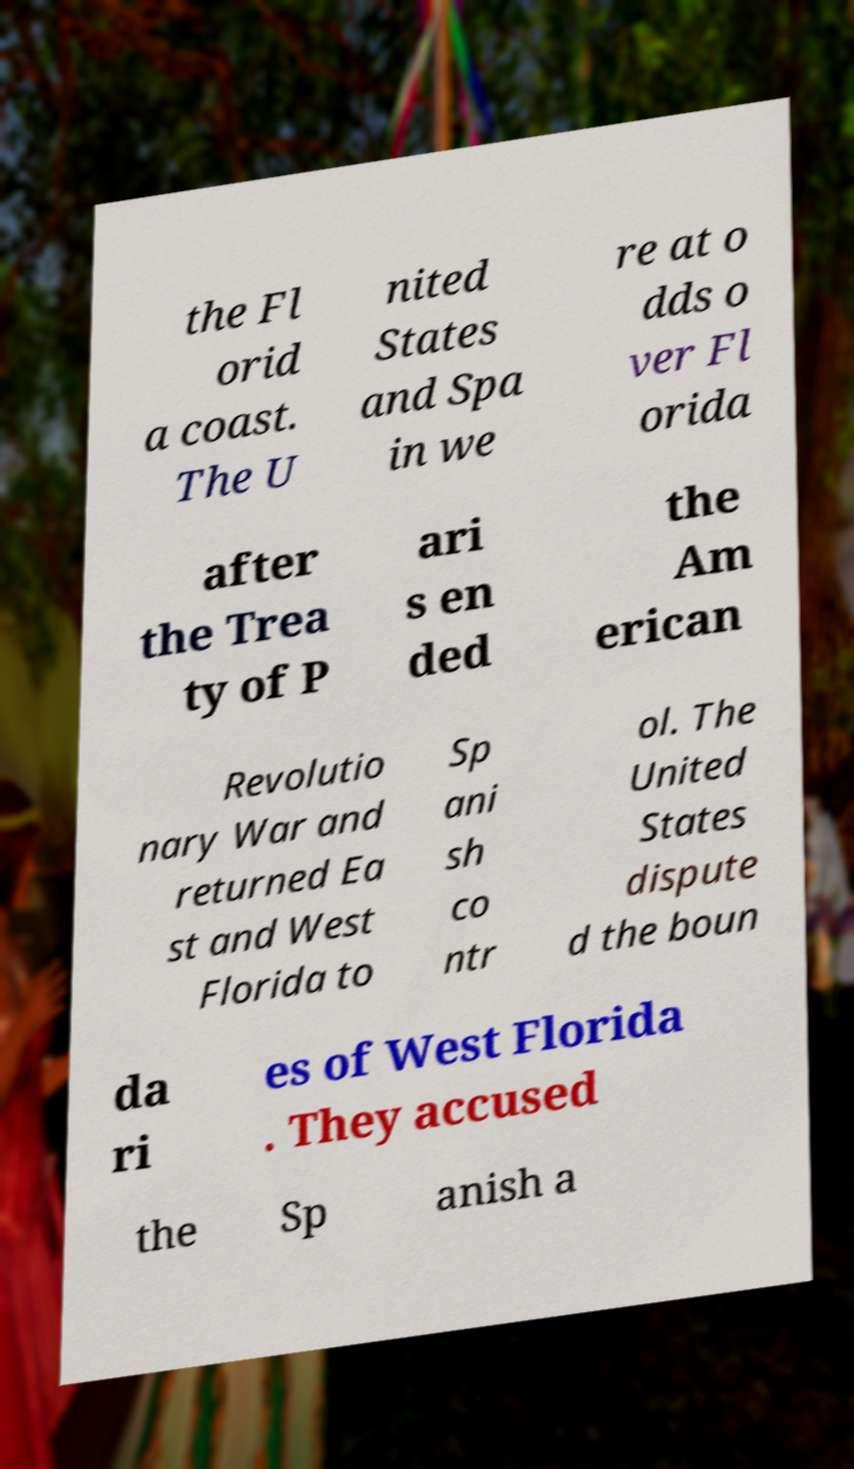Please read and relay the text visible in this image. What does it say? the Fl orid a coast. The U nited States and Spa in we re at o dds o ver Fl orida after the Trea ty of P ari s en ded the Am erican Revolutio nary War and returned Ea st and West Florida to Sp ani sh co ntr ol. The United States dispute d the boun da ri es of West Florida . They accused the Sp anish a 